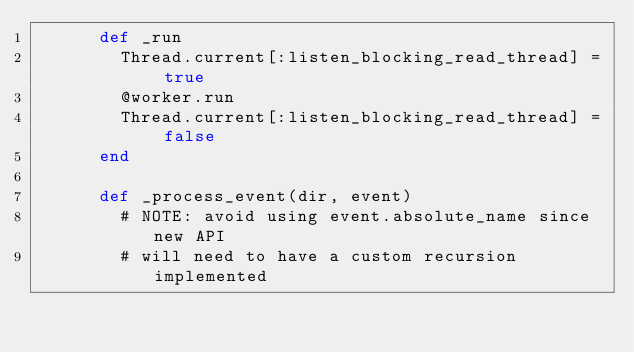<code> <loc_0><loc_0><loc_500><loc_500><_Ruby_>      def _run
        Thread.current[:listen_blocking_read_thread] = true
        @worker.run
        Thread.current[:listen_blocking_read_thread] = false
      end

      def _process_event(dir, event)
        # NOTE: avoid using event.absolute_name since new API
        # will need to have a custom recursion implemented</code> 